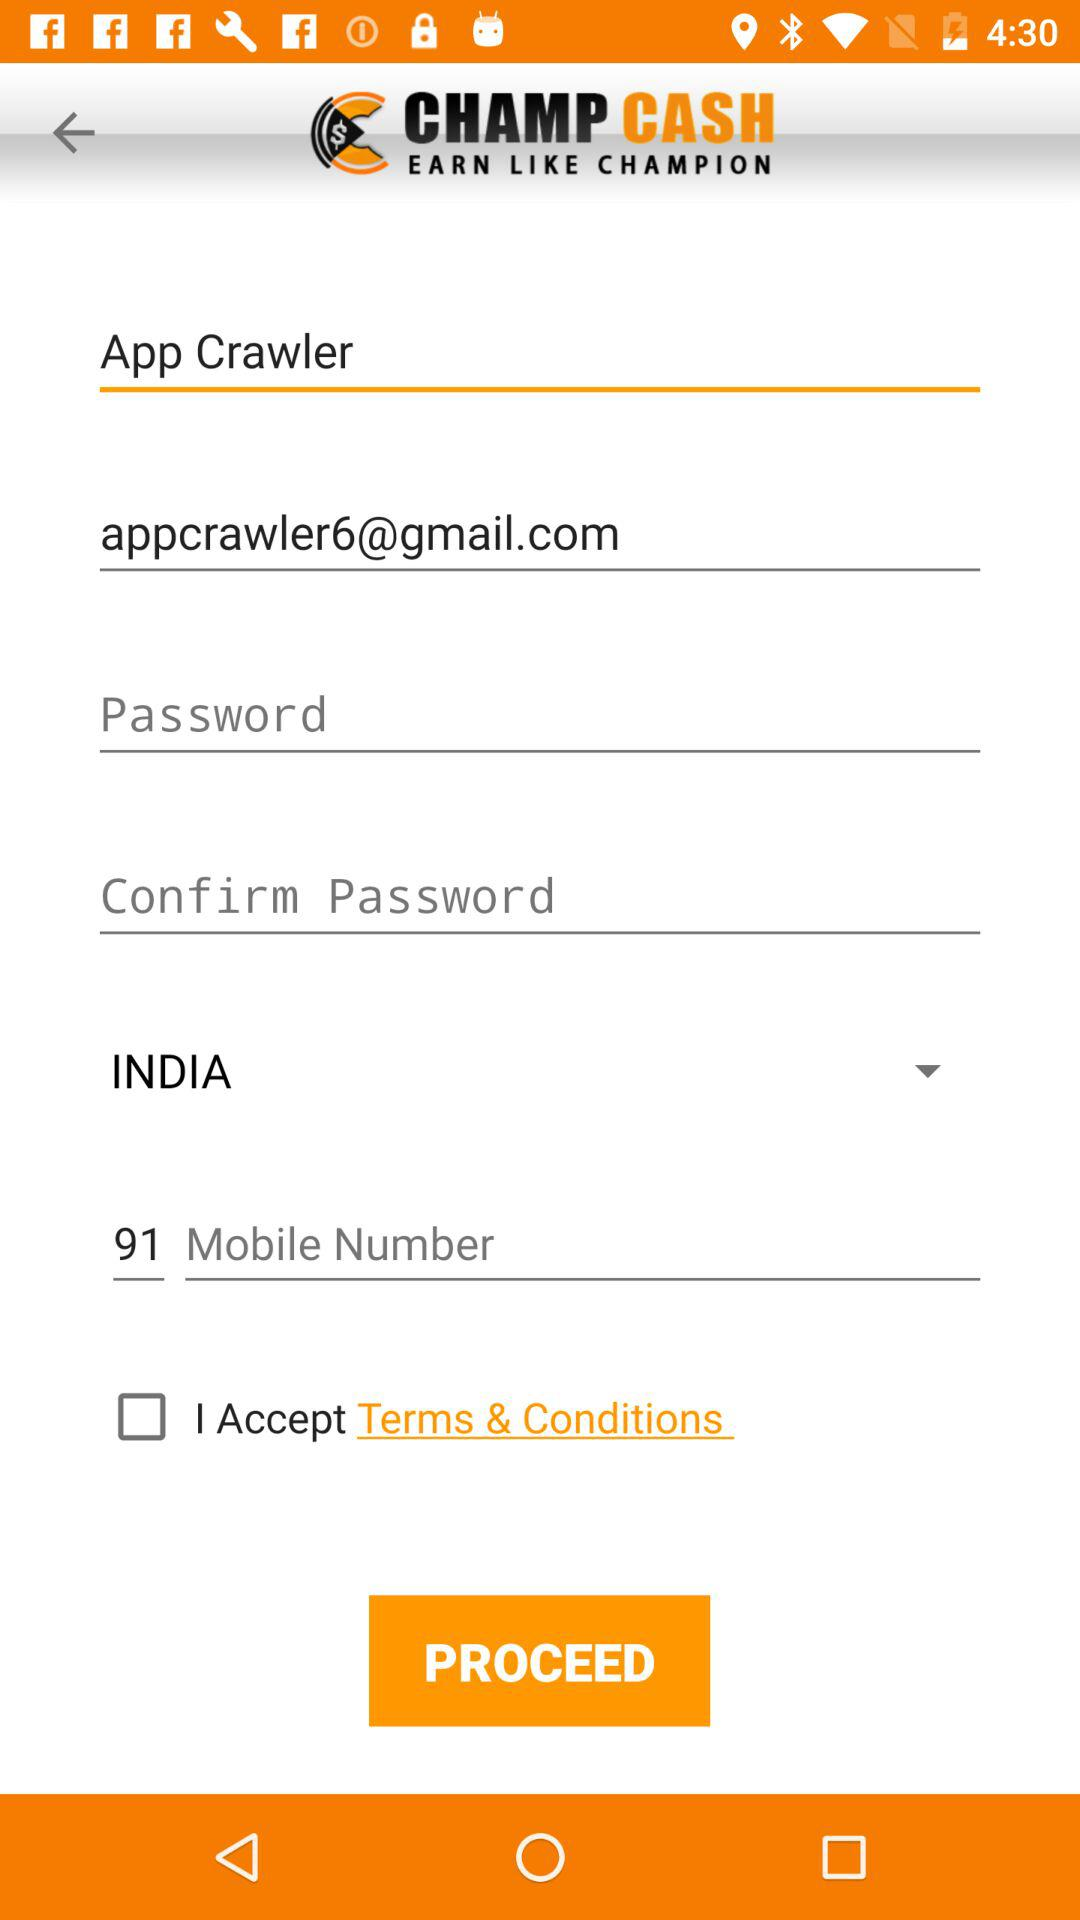Where is the user from? The user is from India. 